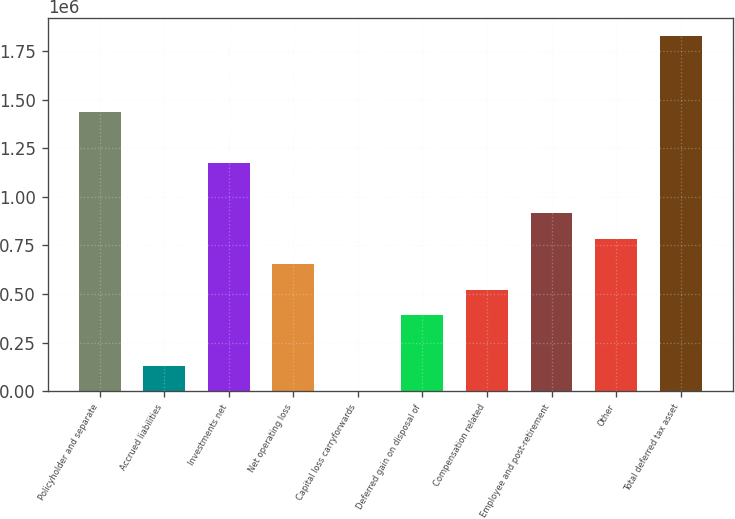Convert chart. <chart><loc_0><loc_0><loc_500><loc_500><bar_chart><fcel>Policyholder and separate<fcel>Accrued liabilities<fcel>Investments net<fcel>Net operating loss<fcel>Capital loss carryforwards<fcel>Deferred gain on disposal of<fcel>Compensation related<fcel>Employee and post-retirement<fcel>Other<fcel>Total deferred tax asset<nl><fcel>1.43689e+06<fcel>130630<fcel>1.17564e+06<fcel>653136<fcel>4.1<fcel>391883<fcel>522509<fcel>914388<fcel>783762<fcel>1.82877e+06<nl></chart> 